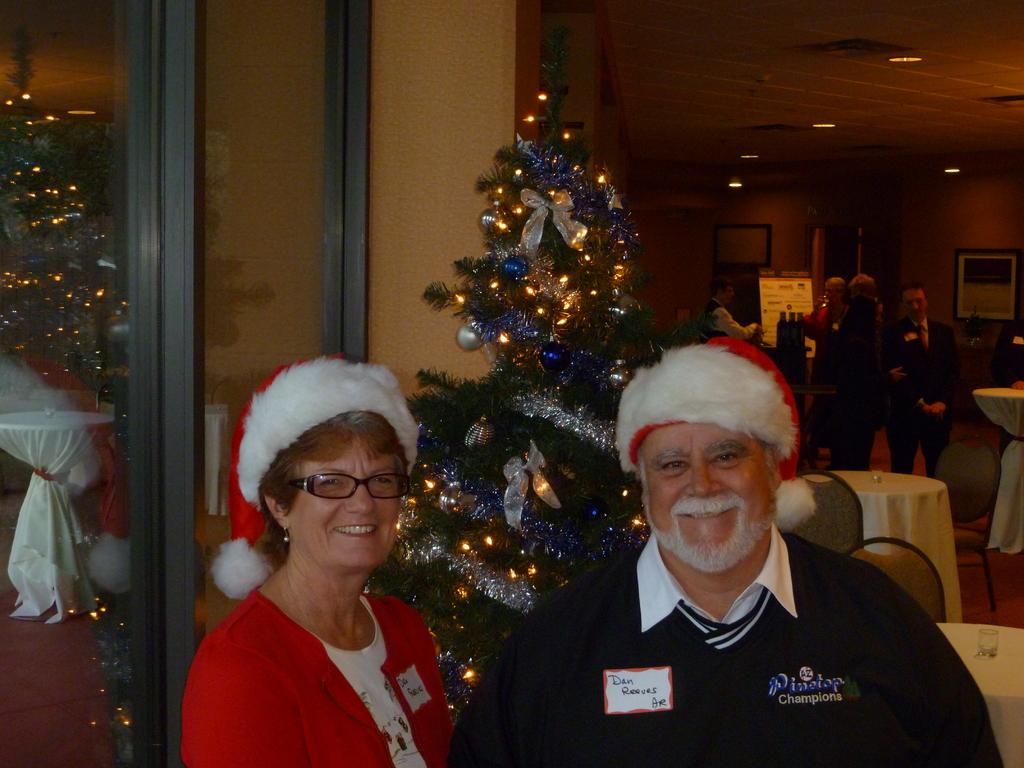What is the man's name?
Give a very brief answer. Dan reeves. 